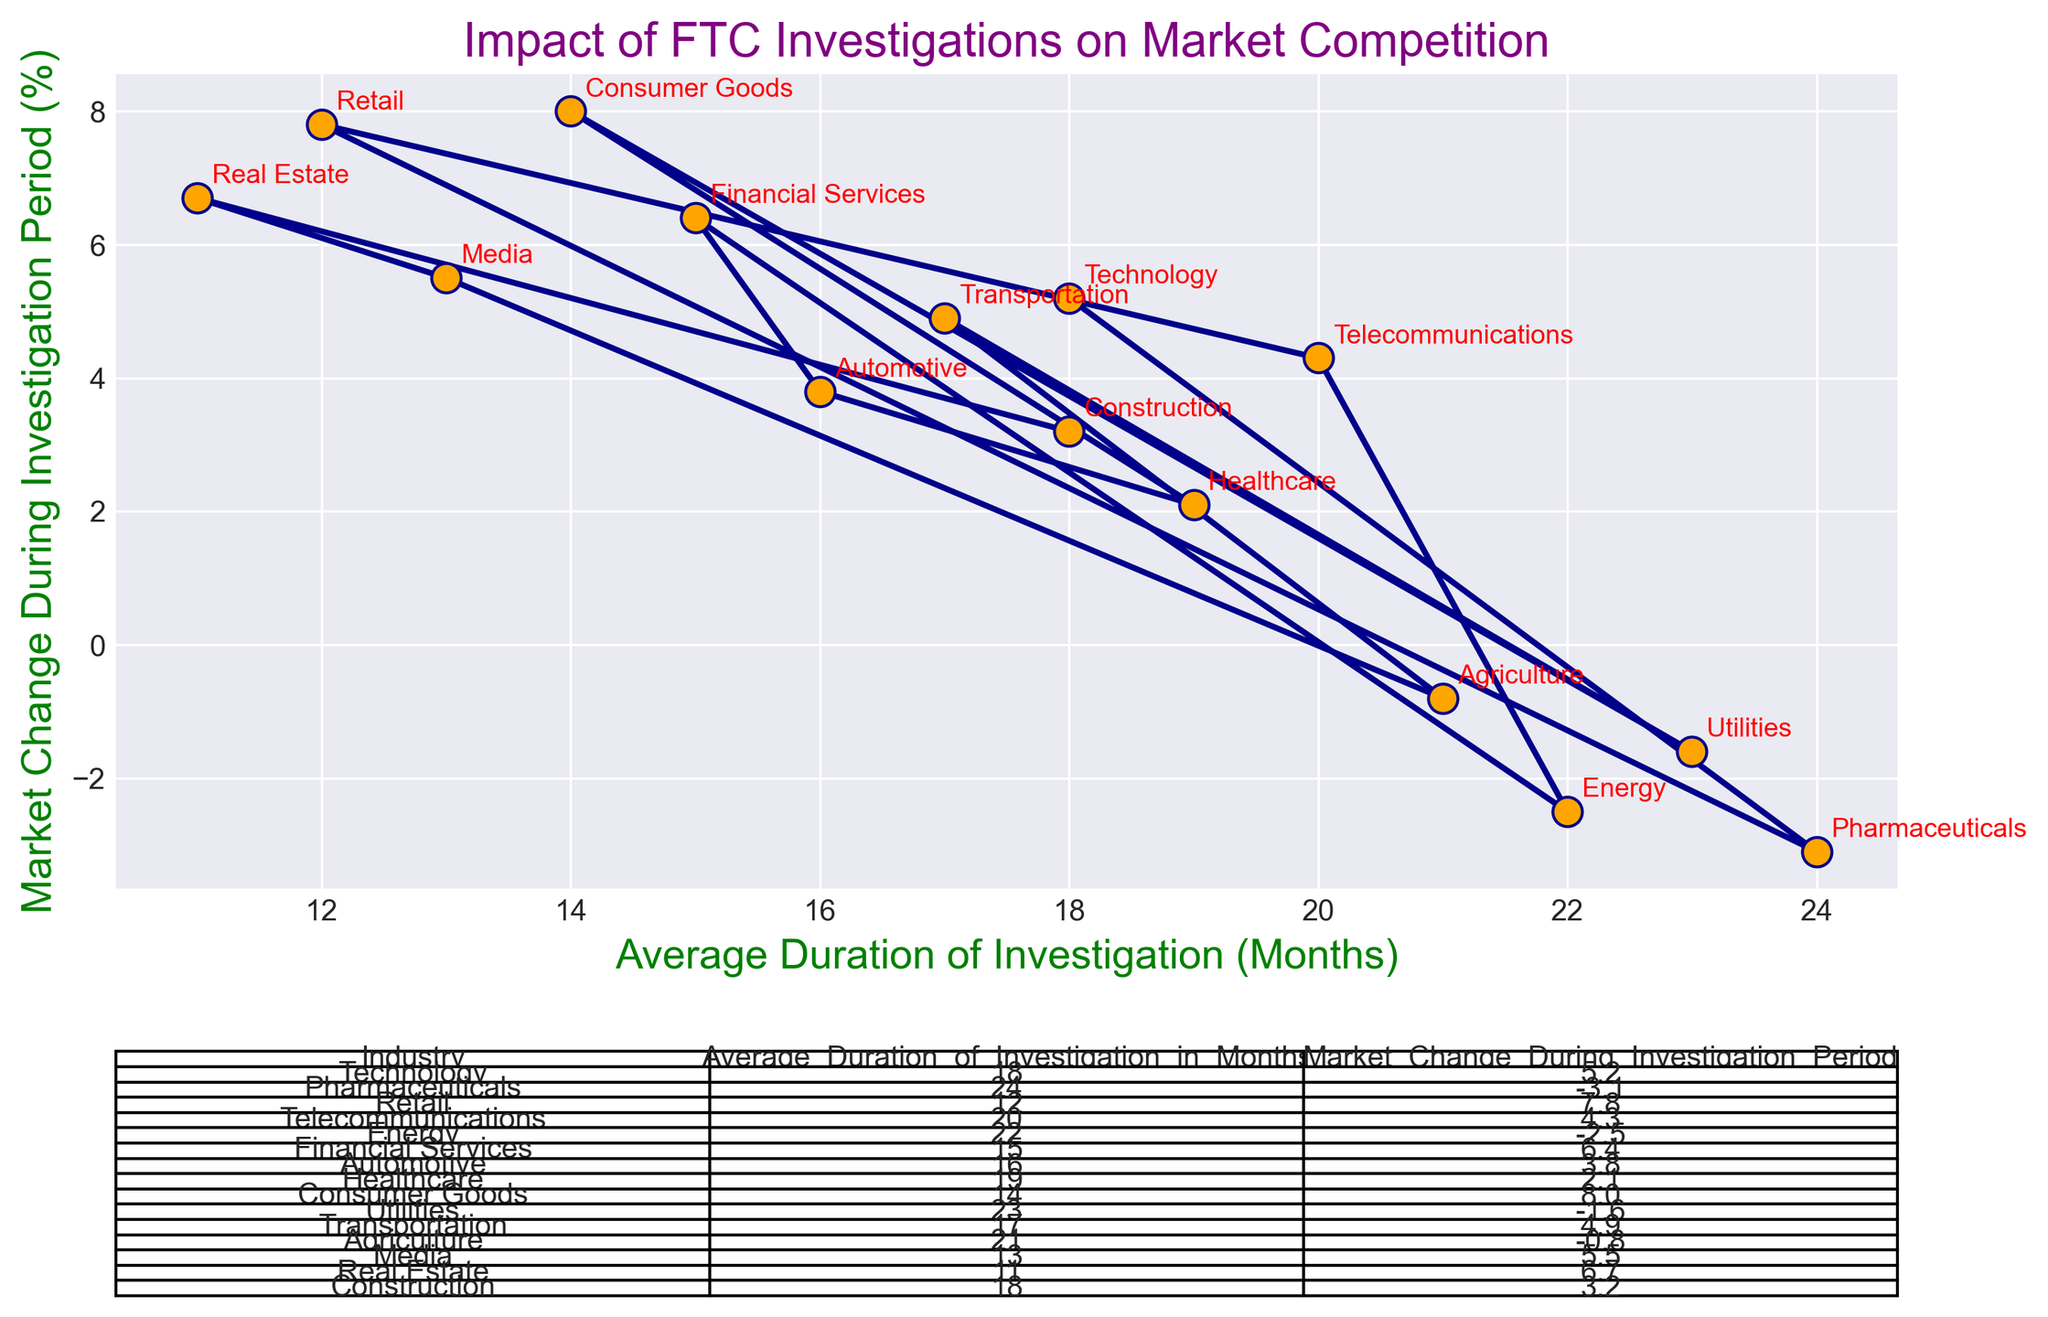Which industry has the shortest average duration of FTC investigations? The 'Real Estate' industry has the shortest duration with 11 months, as marked on the X-axis.
Answer: Real Estate Which industries experienced a market change greater than 5% during the FTC investigation period? 'Retail', 'Consumer Goods', 'Real Estate', 'Financial Services', 'Media', and 'Transportation' experienced market changes greater than 5%, as indicated by their corresponding positive changes on the Y-axis.
Answer: Retail, Consumer Goods, Real Estate, Financial Services, Media, Transportation What is the market change during investigation for the pharmaceuticals industry? The 'Pharmaceuticals' industry shows a market change of -3.1% during the investigation, as indicated by its position on the Y-axis.
Answer: -3.1% Which industry shows the highest market change during the investigation period? The 'Consumer Goods' industry shows the highest market change of 8.0%, as marked on the chart at its highest point on the Y-axis.
Answer: Consumer Goods Calculate the average market change for industries with an investigation duration of more than 20 months. The industries with an average investigation duration of more than 20 months are Pharmaceuticals (-3.1%), Energy (-2.5%), Utilities (-1.6%), and Agriculture (-0.8%). Average market change: (-3.1 + -2.5 + -1.6 + -0.8) / 4 = -2.0
Answer: -2.0 Compare the investigation duration between the Technology and Telecommunications industries. Which one is longer? The 'Telecommunications' industry has an average investigation duration of 20 months, whereas the 'Technology' industry has 18 months. 20 > 18, so Telecommunications has a longer investigation duration.
Answer: Telecommunications What is the relationship between the average investigation duration and market change for the healthcare industry? For the 'Healthcare' industry, the average investigation duration is 19 months, and the market change is 2.1%, as marked on the chart.
Answer: 19 months, 2.1% Which industry experienced a negative market change during its investigation period despite having a relatively high duration? The 'Pharmaceuticals' industry experienced a market change of -3.1% with a duration of 24 months, as indicated on the chart in the negative Y-axis section.
Answer: Pharmaceuticals What is the median average duration of investigations across all industries? To find the median, arrange the durations [11, 12, 13, 14, 15, 16, 17, 18, 18, 19, 20, 21, 22, 23, 24] and find the middle value. The median is the 8th value: 18 months.
Answer: 18 months What is the difference in market change during the investigation period between the Retail and Automotive industries? The 'Retail' industry has a market change of 7.8%, while the 'Automotive' industry has 3.8%. The difference is 7.8 - 3.8 = 4.0%.
Answer: 4.0% 